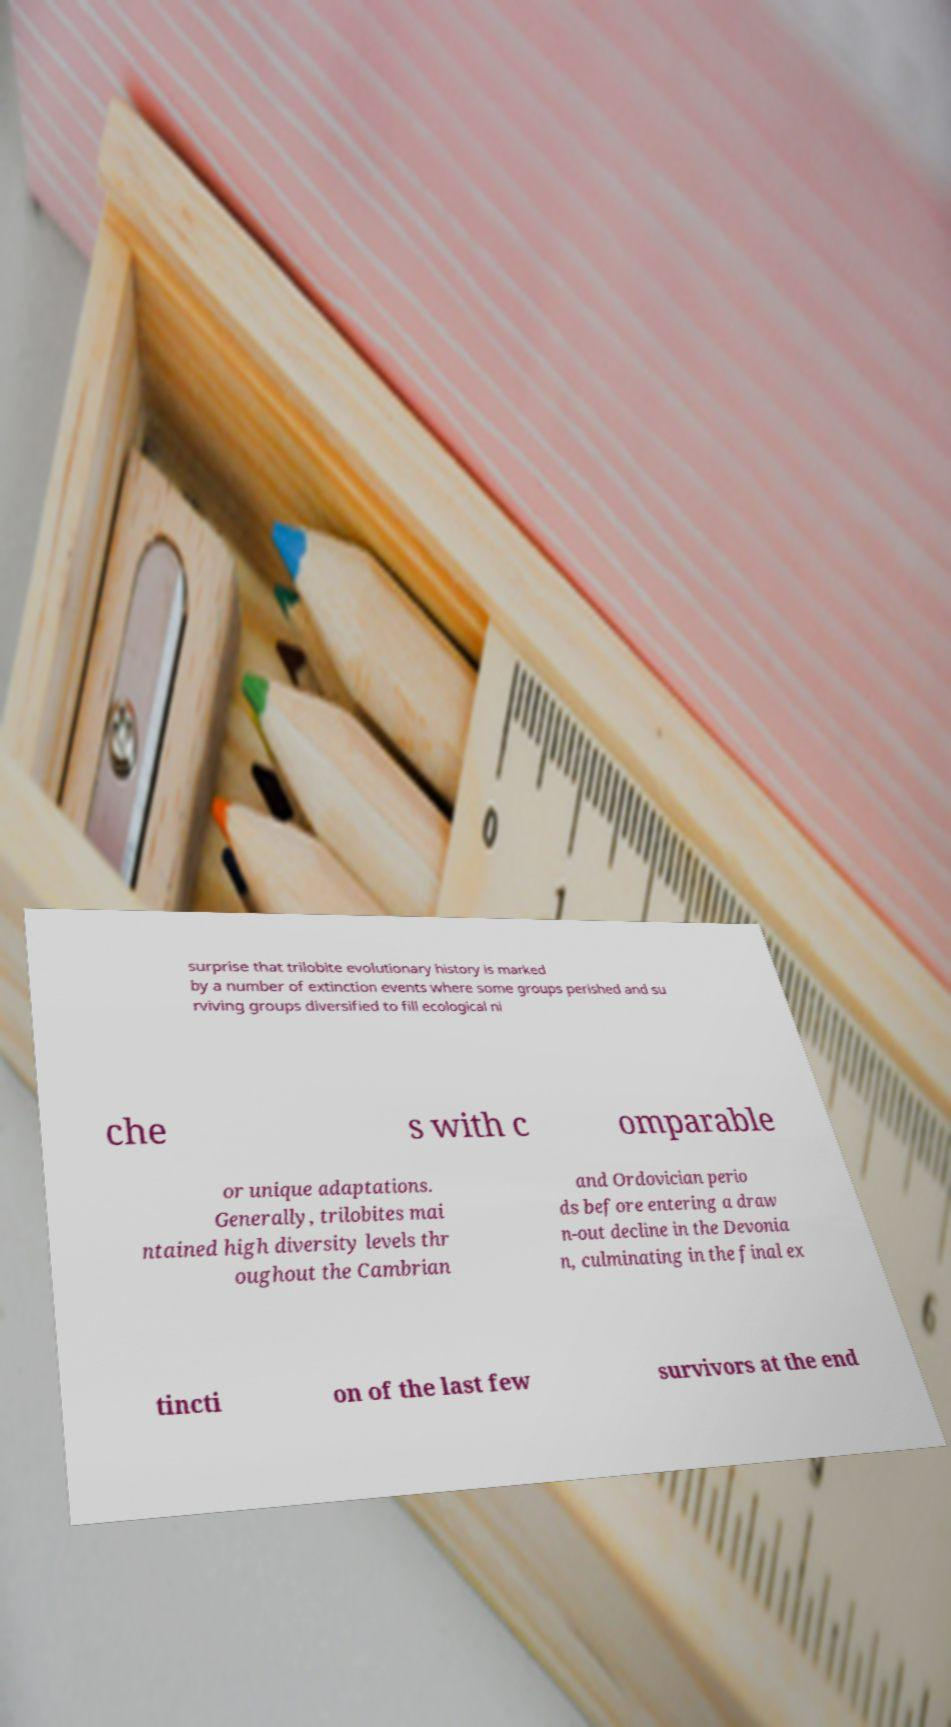What messages or text are displayed in this image? I need them in a readable, typed format. surprise that trilobite evolutionary history is marked by a number of extinction events where some groups perished and su rviving groups diversified to fill ecological ni che s with c omparable or unique adaptations. Generally, trilobites mai ntained high diversity levels thr oughout the Cambrian and Ordovician perio ds before entering a draw n-out decline in the Devonia n, culminating in the final ex tincti on of the last few survivors at the end 